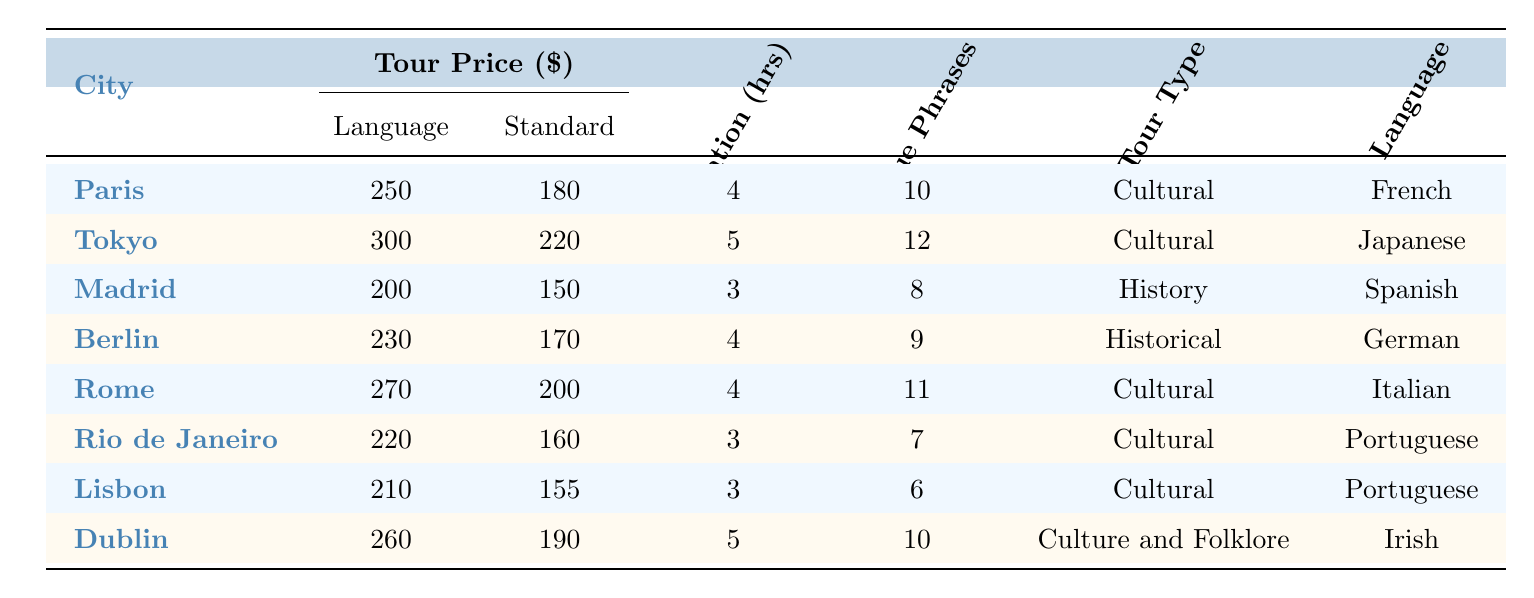What is the price of the language tour in Berlin? The table indicates that the Language Tour Price for Berlin is listed as $230.
Answer: 230 What is the tour duration in Tokyo? According to the table, the Tour Duration for Tokyo is 5 hours.
Answer: 5 hours Which city has the highest unique phrases learned on a language tour? By comparing the 'Unique Phrases Learned' column, Tokyo has the most at 12 phrases.
Answer: Tokyo How much more expensive is the language tour compared to the standard tour in Paris? The difference in price between the Language Tour ($250) and Standard Tour ($180) in Paris is calculated as 250 - 180 = 70.
Answer: 70 What is the average price of language tours across all cities? First, we add the prices: 250 + 300 + 200 + 230 + 270 + 220 + 210 + 260 = 1,740. Next, we divide by the number of tours (8): 1,740 / 8 = 217.5.
Answer: 217.5 Is the language tour in Rome cheaper than the standard tour? The Language Tour price in Rome is $270, and the Standard Tour price is $200, thus 270 is greater than 200.
Answer: No Which city offers the lowest standard tour price? Examining the 'Standard Tour Price' column, Madrid has the lowest price at $150.
Answer: Madrid What is the total number of unique phrases learned across all language tours? We sum the unique phrases learned: 10 + 12 + 8 + 9 + 11 + 7 + 6 + 10 = 73.
Answer: 73 Which city has a longer tour duration, Lisbon or Rome? The table shows Lisbon has a duration of 3 hours and Rome has 4 hours. Since 4 hours > 3 hours, Rome has a longer duration.
Answer: Rome What percentage increase in price does the language tour represent compared to the standard tour in Dublin? The difference in price is 260 - 190 = 70. The percentage increase is calculated as (70 / 190) * 100 = 36.84%.
Answer: 36.84% 